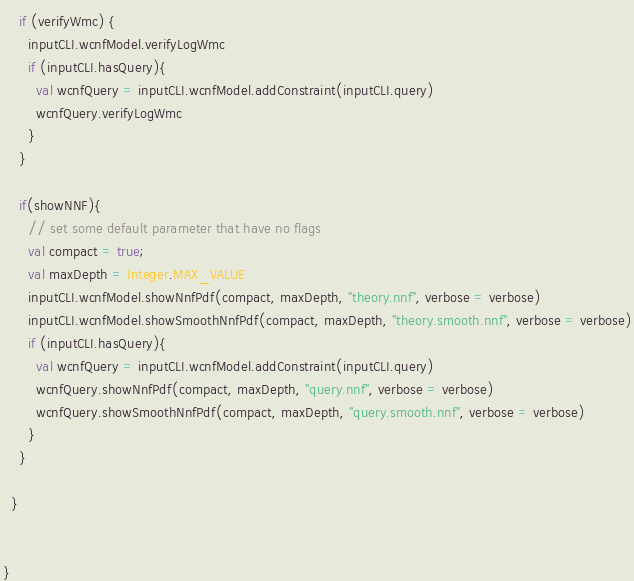Convert code to text. <code><loc_0><loc_0><loc_500><loc_500><_Scala_>    if (verifyWmc) {
      inputCLI.wcnfModel.verifyLogWmc
      if (inputCLI.hasQuery){
        val wcnfQuery = inputCLI.wcnfModel.addConstraint(inputCLI.query)
        wcnfQuery.verifyLogWmc
      }
    }
    
    if(showNNF){
      // set some default parameter that have no flags
      val compact = true;
      val maxDepth = Integer.MAX_VALUE
      inputCLI.wcnfModel.showNnfPdf(compact, maxDepth, "theory.nnf", verbose = verbose)
      inputCLI.wcnfModel.showSmoothNnfPdf(compact, maxDepth, "theory.smooth.nnf", verbose = verbose)
      if (inputCLI.hasQuery){
        val wcnfQuery = inputCLI.wcnfModel.addConstraint(inputCLI.query)
        wcnfQuery.showNnfPdf(compact, maxDepth, "query.nnf", verbose = verbose)
        wcnfQuery.showSmoothNnfPdf(compact, maxDepth, "query.smooth.nnf", verbose = verbose)
      }
    }
    
  }

  
}
</code> 